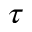<formula> <loc_0><loc_0><loc_500><loc_500>\tau</formula> 